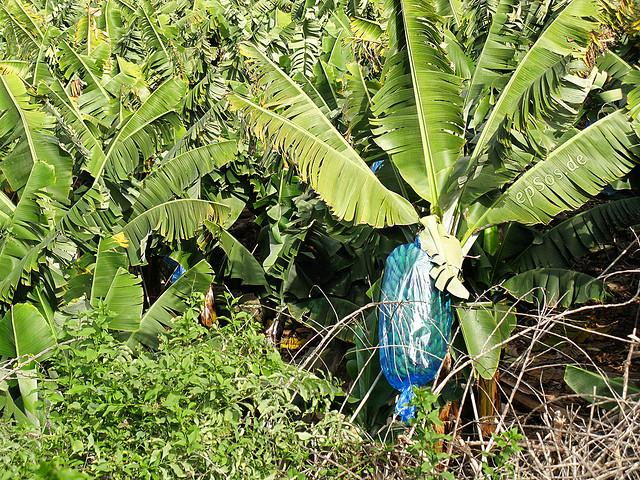What fruit is in the bright blue bag? bananas 